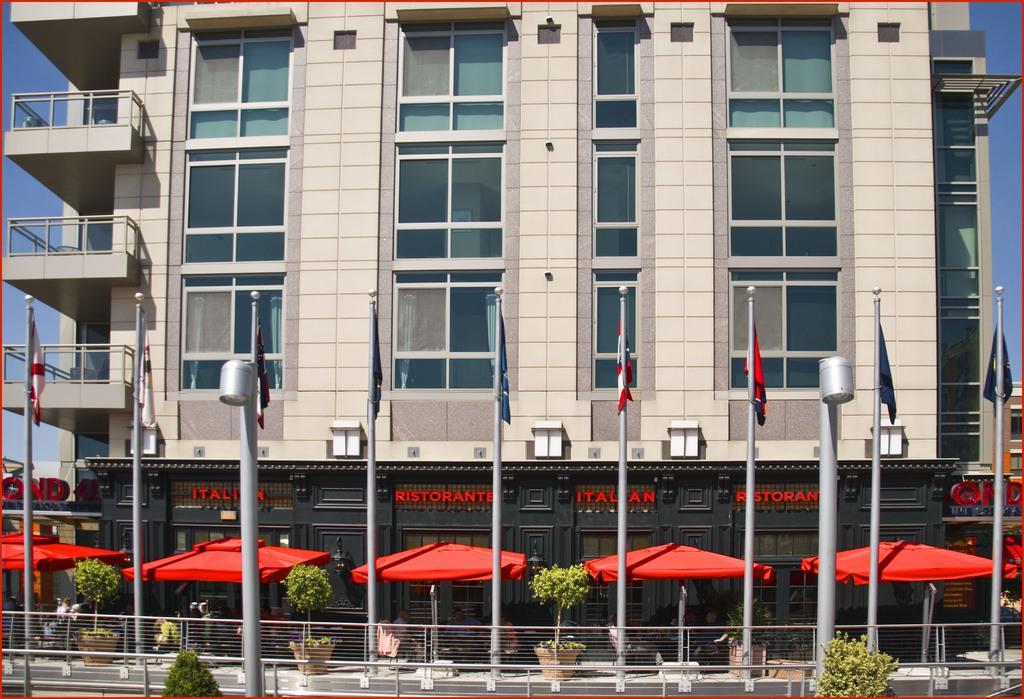In one or two sentences, can you explain what this image depicts? In this image we can see the building with the glass windows. We can also see the flags, light poles, flower pots, plants and also the barrier. We can also see the red color tents for shelter. Sky is also visible in this image and the image has borders. 